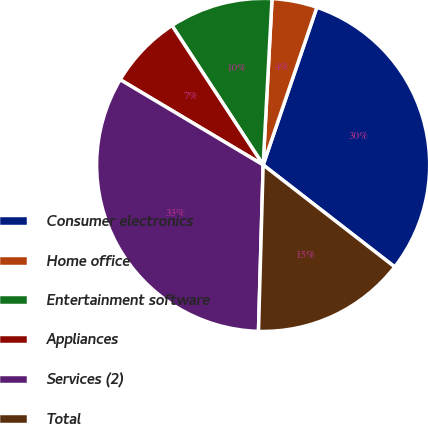Convert chart to OTSL. <chart><loc_0><loc_0><loc_500><loc_500><pie_chart><fcel>Consumer electronics<fcel>Home office<fcel>Entertainment software<fcel>Appliances<fcel>Services (2)<fcel>Total<nl><fcel>30.27%<fcel>4.38%<fcel>10.07%<fcel>7.22%<fcel>33.11%<fcel>14.95%<nl></chart> 